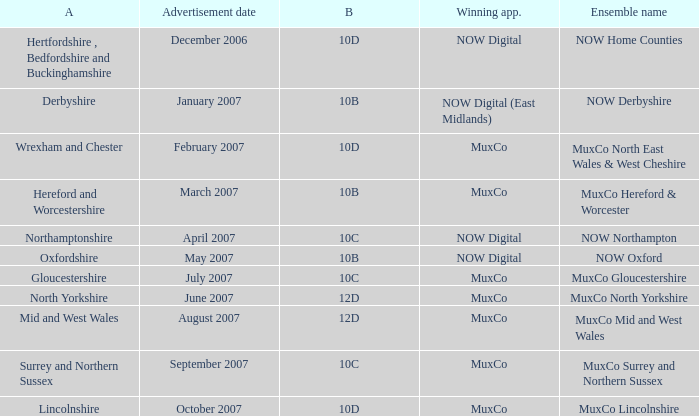Could you parse the entire table? {'header': ['A', 'Advertisement date', 'B', 'Winning app.', 'Ensemble name'], 'rows': [['Hertfordshire , Bedfordshire and Buckinghamshire', 'December 2006', '10D', 'NOW Digital', 'NOW Home Counties'], ['Derbyshire', 'January 2007', '10B', 'NOW Digital (East Midlands)', 'NOW Derbyshire'], ['Wrexham and Chester', 'February 2007', '10D', 'MuxCo', 'MuxCo North East Wales & West Cheshire'], ['Hereford and Worcestershire', 'March 2007', '10B', 'MuxCo', 'MuxCo Hereford & Worcester'], ['Northamptonshire', 'April 2007', '10C', 'NOW Digital', 'NOW Northampton'], ['Oxfordshire', 'May 2007', '10B', 'NOW Digital', 'NOW Oxford'], ['Gloucestershire', 'July 2007', '10C', 'MuxCo', 'MuxCo Gloucestershire'], ['North Yorkshire', 'June 2007', '12D', 'MuxCo', 'MuxCo North Yorkshire'], ['Mid and West Wales', 'August 2007', '12D', 'MuxCo', 'MuxCo Mid and West Wales'], ['Surrey and Northern Sussex', 'September 2007', '10C', 'MuxCo', 'MuxCo Surrey and Northern Sussex'], ['Lincolnshire', 'October 2007', '10D', 'MuxCo', 'MuxCo Lincolnshire']]} What is Oxfordshire Area's Ensemble Name? NOW Oxford. 